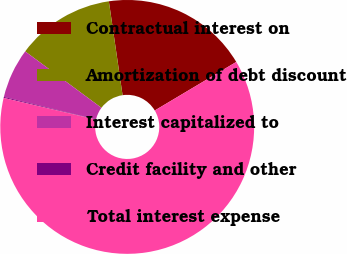Convert chart. <chart><loc_0><loc_0><loc_500><loc_500><pie_chart><fcel>Contractual interest on<fcel>Amortization of debt discount<fcel>Interest capitalized to<fcel>Credit facility and other<fcel>Total interest expense<nl><fcel>18.76%<fcel>12.55%<fcel>6.34%<fcel>0.13%<fcel>62.22%<nl></chart> 